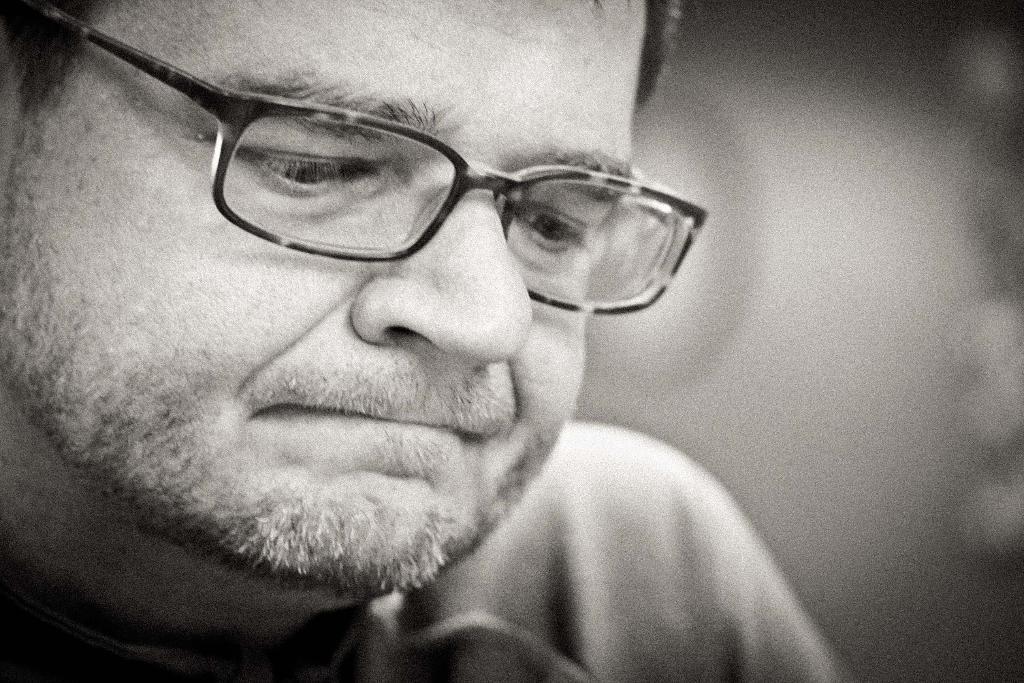In one or two sentences, can you explain what this image depicts? It is a black and white picture. On the left side of the image we can see a person wore spectacles. On the right side of the image it is blurry. 